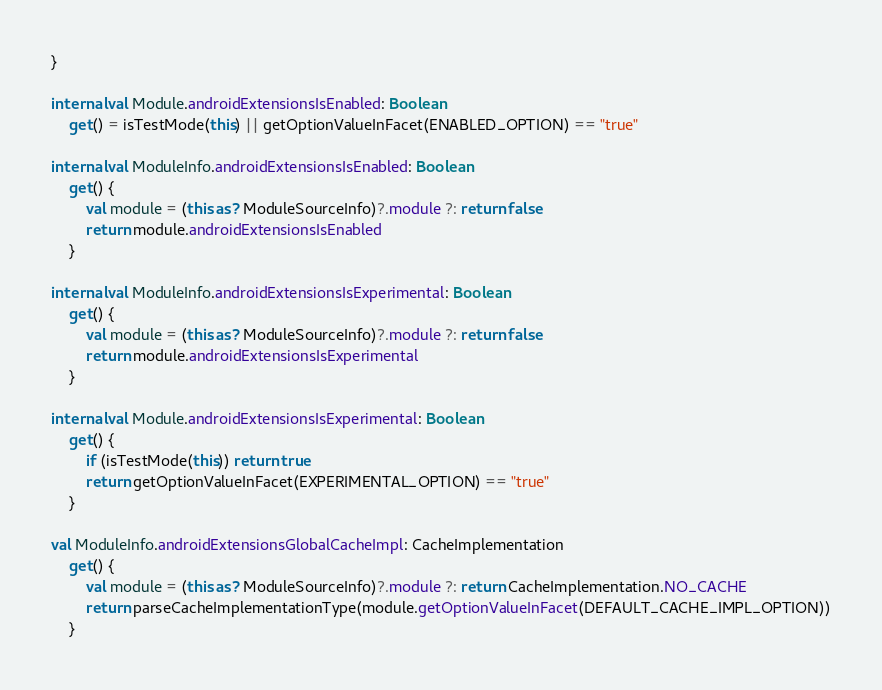<code> <loc_0><loc_0><loc_500><loc_500><_Kotlin_>}

internal val Module.androidExtensionsIsEnabled: Boolean
    get() = isTestMode(this) || getOptionValueInFacet(ENABLED_OPTION) == "true"

internal val ModuleInfo.androidExtensionsIsEnabled: Boolean
    get() {
        val module = (this as? ModuleSourceInfo)?.module ?: return false
        return module.androidExtensionsIsEnabled
    }

internal val ModuleInfo.androidExtensionsIsExperimental: Boolean
    get() {
        val module = (this as? ModuleSourceInfo)?.module ?: return false
        return module.androidExtensionsIsExperimental
    }

internal val Module.androidExtensionsIsExperimental: Boolean
    get() {
        if (isTestMode(this)) return true
        return getOptionValueInFacet(EXPERIMENTAL_OPTION) == "true"
    }

val ModuleInfo.androidExtensionsGlobalCacheImpl: CacheImplementation
    get() {
        val module = (this as? ModuleSourceInfo)?.module ?: return CacheImplementation.NO_CACHE
        return parseCacheImplementationType(module.getOptionValueInFacet(DEFAULT_CACHE_IMPL_OPTION))
    }</code> 